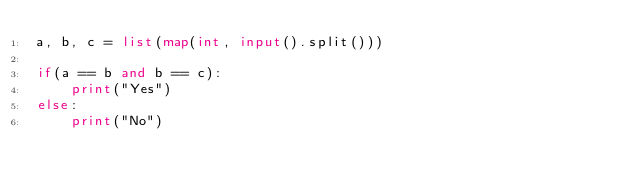Convert code to text. <code><loc_0><loc_0><loc_500><loc_500><_Python_>a, b, c = list(map(int, input().split()))

if(a == b and b == c):
	print("Yes")
else:
	print("No")</code> 